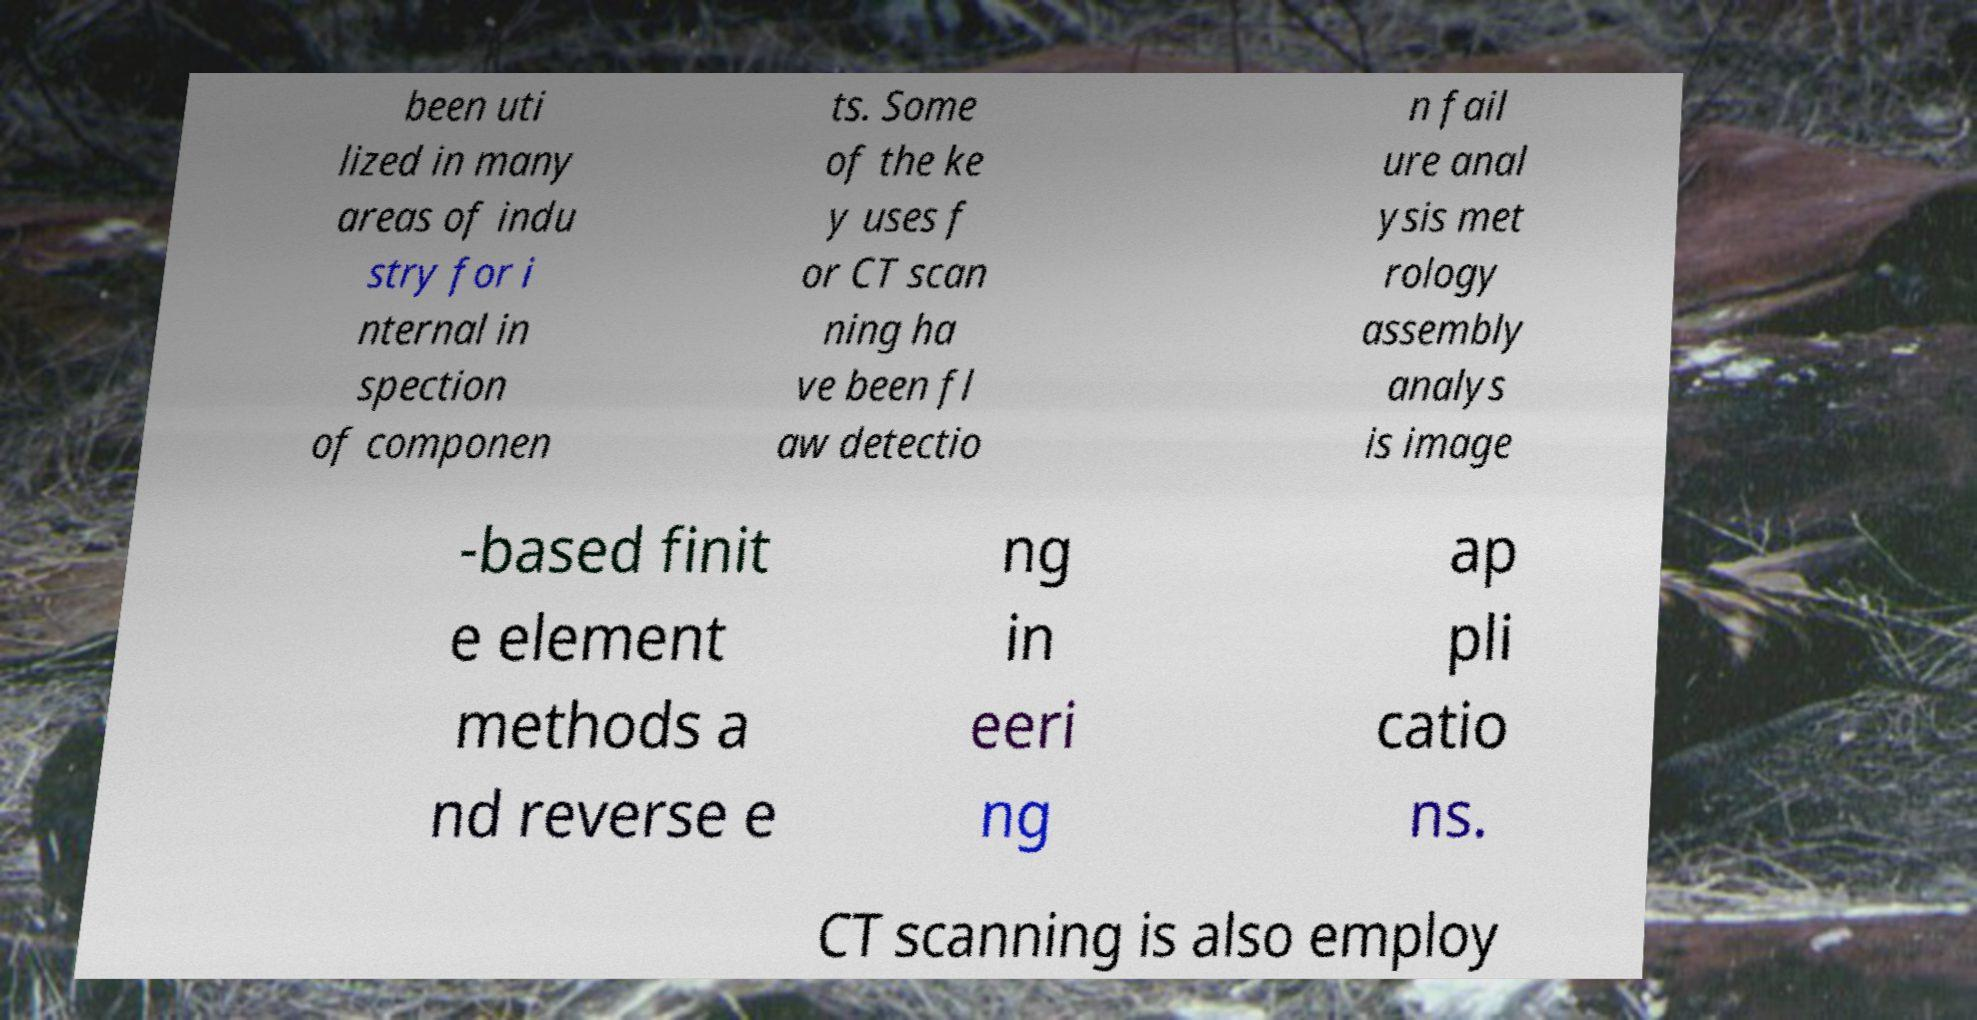Can you accurately transcribe the text from the provided image for me? been uti lized in many areas of indu stry for i nternal in spection of componen ts. Some of the ke y uses f or CT scan ning ha ve been fl aw detectio n fail ure anal ysis met rology assembly analys is image -based finit e element methods a nd reverse e ng in eeri ng ap pli catio ns. CT scanning is also employ 